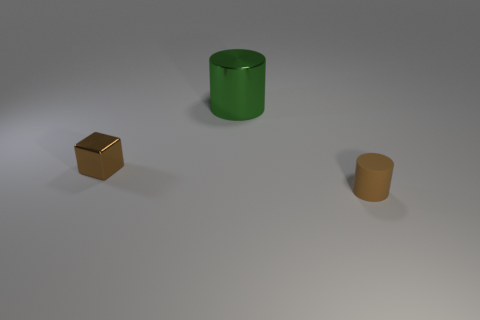What number of brown objects are in front of the tiny object that is right of the brown shiny object?
Provide a short and direct response. 0. What number of green things have the same material as the brown cylinder?
Give a very brief answer. 0. How many tiny objects are either green objects or blue shiny blocks?
Your response must be concise. 0. The thing that is left of the tiny matte object and to the right of the block has what shape?
Give a very brief answer. Cylinder. Is the brown cylinder made of the same material as the big cylinder?
Give a very brief answer. No. What is the color of the metal object that is the same size as the brown matte object?
Offer a very short reply. Brown. What is the color of the thing that is both behind the small matte thing and right of the block?
Your response must be concise. Green. What size is the shiny block that is the same color as the rubber object?
Make the answer very short. Small. What is the shape of the small thing that is the same color as the tiny matte cylinder?
Make the answer very short. Cube. What size is the thing in front of the brown thing that is behind the thing that is to the right of the big object?
Offer a very short reply. Small. 